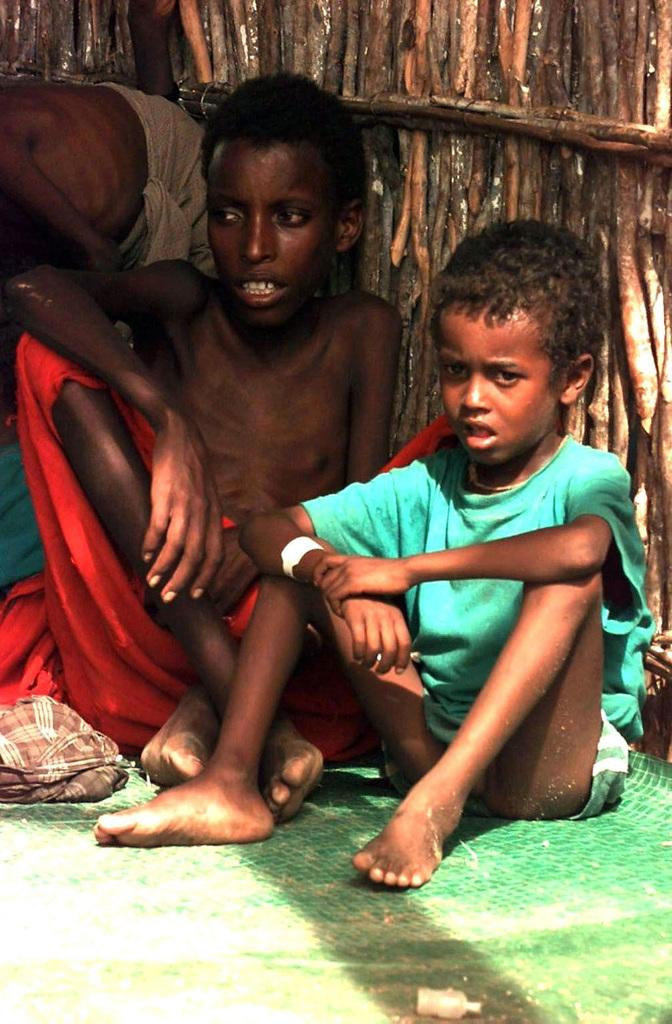What are the people in the image doing? The people in the image are sitting. What is at the bottom of the image? There is a mat and clothes at the bottom of the image. What can be seen in the background of the image? There are wooden poles in the background of the image. What is the rate of the cloud's movement in the image? There is no cloud present in the image, so it is not possible to determine the rate of its movement. 